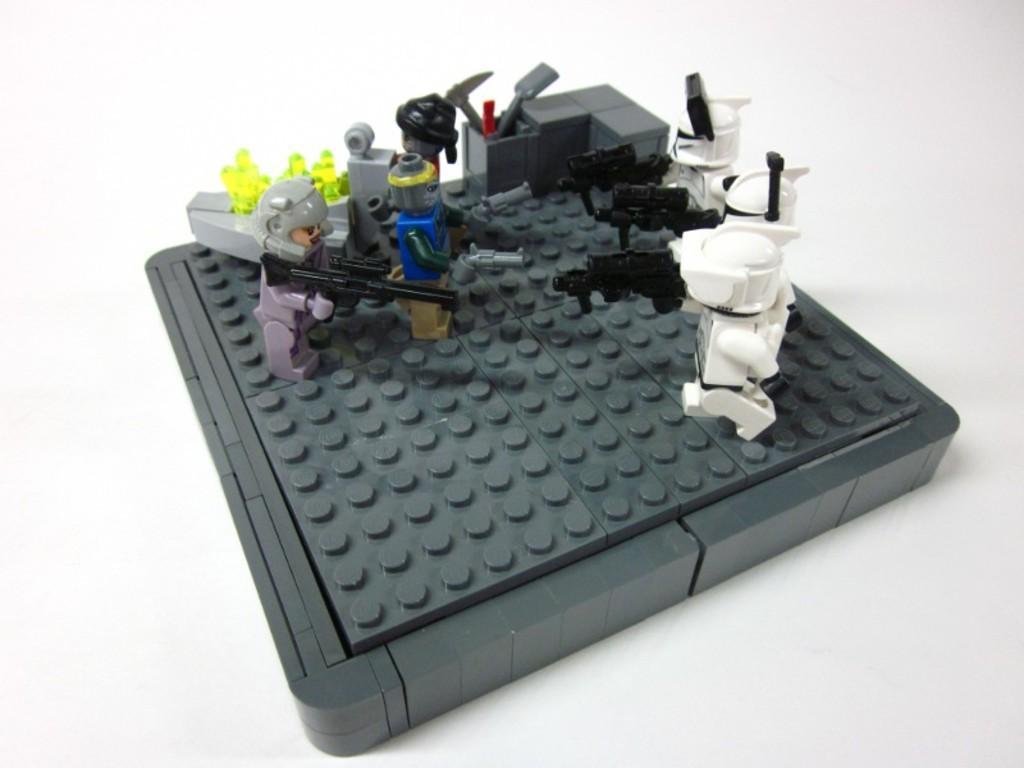Can you describe this image briefly? In this picture I can observe toys in the middle of the picture. I can observe white, black, blue, green and grey color toys in this picture. The background is in white color. 